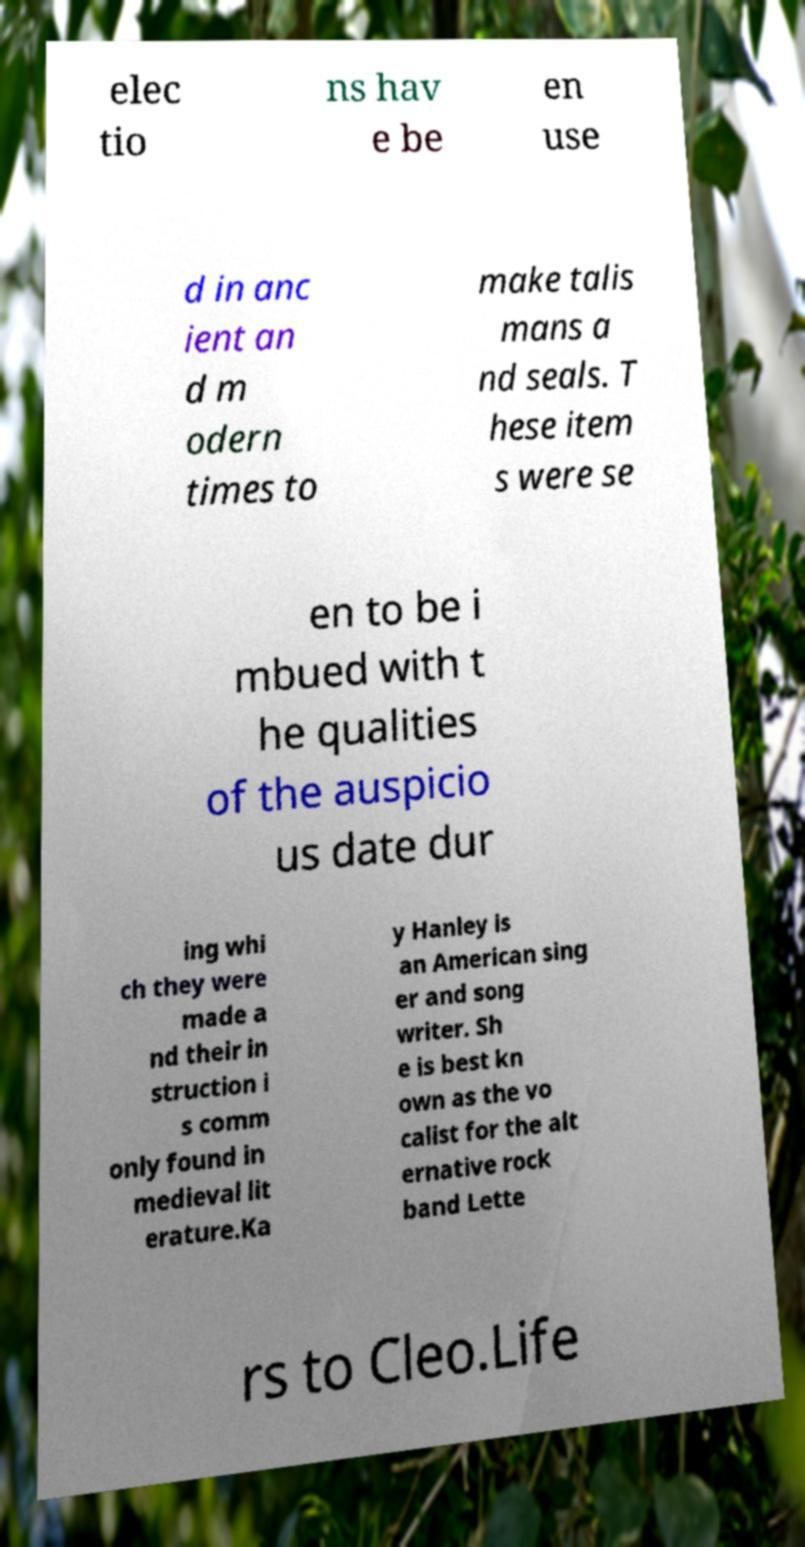I need the written content from this picture converted into text. Can you do that? elec tio ns hav e be en use d in anc ient an d m odern times to make talis mans a nd seals. T hese item s were se en to be i mbued with t he qualities of the auspicio us date dur ing whi ch they were made a nd their in struction i s comm only found in medieval lit erature.Ka y Hanley is an American sing er and song writer. Sh e is best kn own as the vo calist for the alt ernative rock band Lette rs to Cleo.Life 